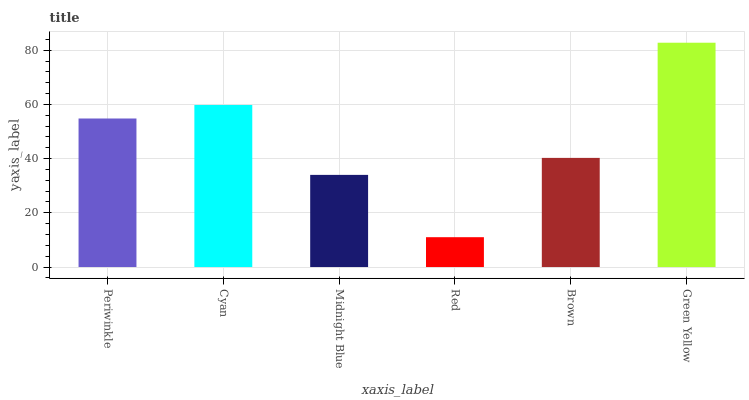Is Red the minimum?
Answer yes or no. Yes. Is Green Yellow the maximum?
Answer yes or no. Yes. Is Cyan the minimum?
Answer yes or no. No. Is Cyan the maximum?
Answer yes or no. No. Is Cyan greater than Periwinkle?
Answer yes or no. Yes. Is Periwinkle less than Cyan?
Answer yes or no. Yes. Is Periwinkle greater than Cyan?
Answer yes or no. No. Is Cyan less than Periwinkle?
Answer yes or no. No. Is Periwinkle the high median?
Answer yes or no. Yes. Is Brown the low median?
Answer yes or no. Yes. Is Green Yellow the high median?
Answer yes or no. No. Is Red the low median?
Answer yes or no. No. 